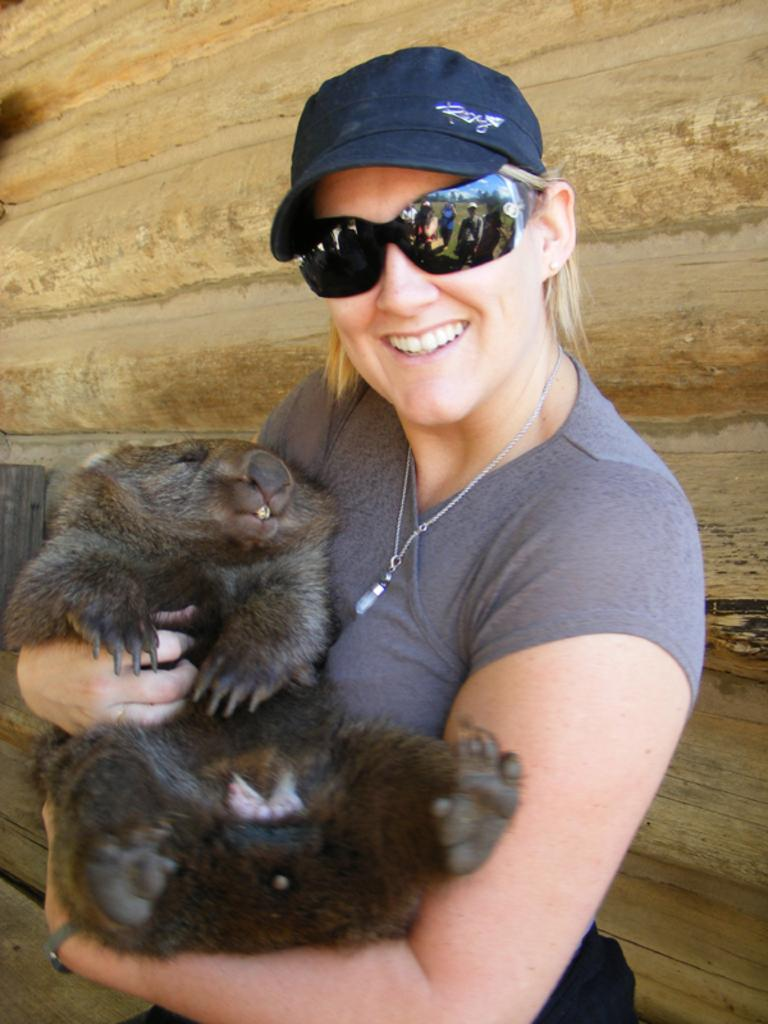Who is present in the image? There is a woman in the image. What is the woman holding in the image? The woman is holding an animal. What is the woman's facial expression in the image? The woman is smiling in the image. What accessories is the woman wearing in the image? The woman is wearing glasses and a cap in the image. What can be seen in the background of the image? There is a wall visible in the background of the image. What type of trains can be seen passing by in the image? There are no trains present in the image; it features a woman holding an animal. How does the minister interact with the woman in the image? There is no minister present in the image; it only features a woman holding an animal. 